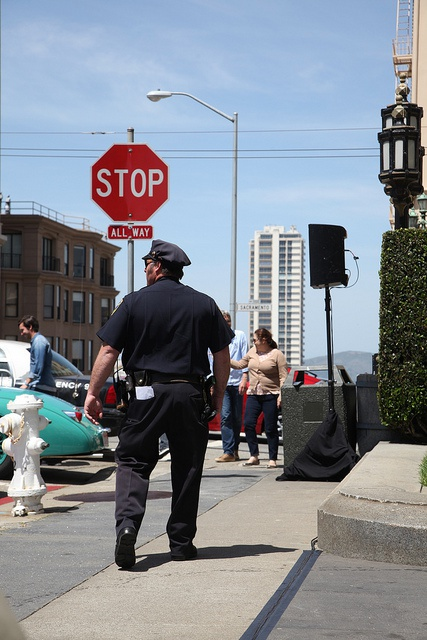Describe the objects in this image and their specific colors. I can see people in gray, black, and darkgray tones, stop sign in gray, maroon, darkgray, lightgray, and brown tones, fire hydrant in gray, white, darkgray, and black tones, people in gray, black, tan, maroon, and darkgray tones, and car in gray, teal, and turquoise tones in this image. 